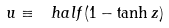<formula> <loc_0><loc_0><loc_500><loc_500>u \equiv \ h a l f ( 1 - \tanh z )</formula> 